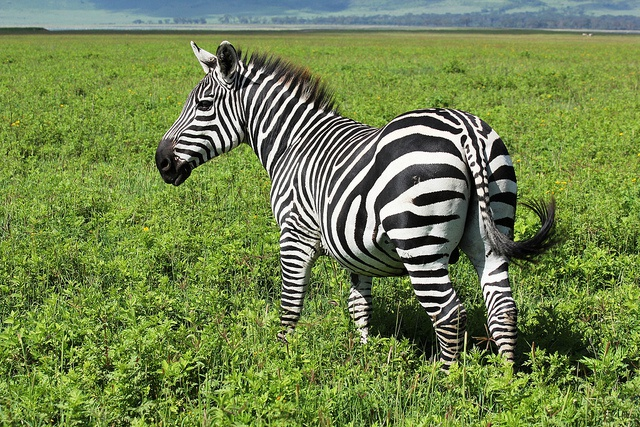Describe the objects in this image and their specific colors. I can see a zebra in gray, black, white, and darkgray tones in this image. 